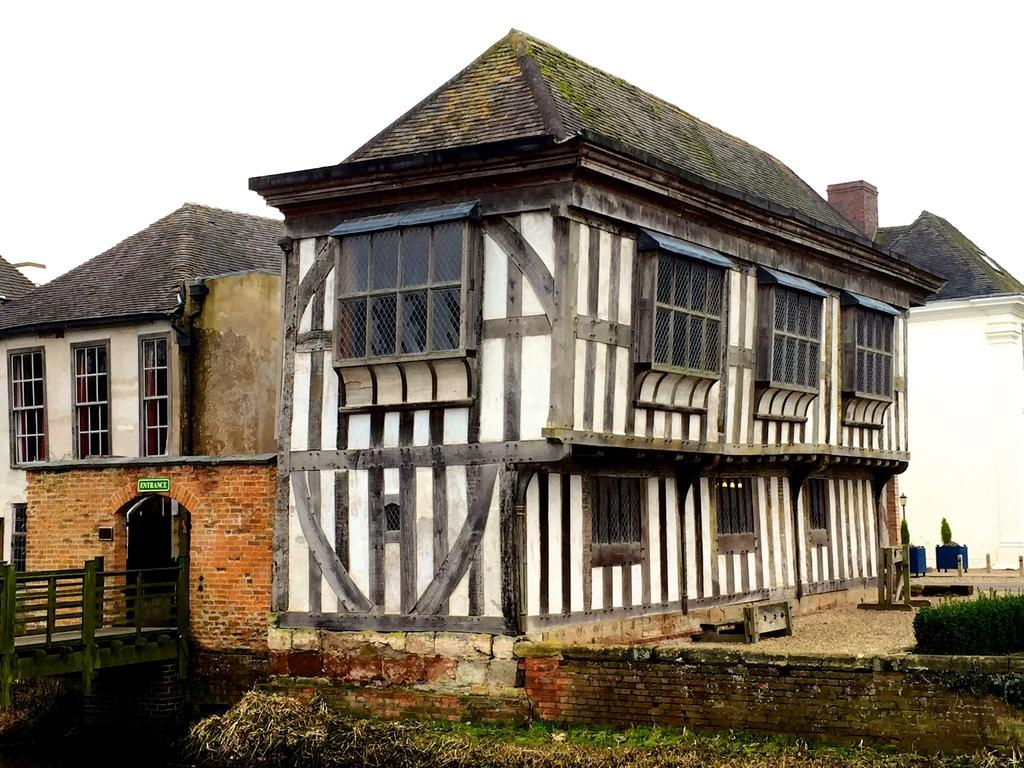What type of structures can be seen in the image? There are houses in the image. What connects the two sides of the image? There is a bridge in the image. What type of vegetation is present in the image? Grass and plants are present in the image. What is visible in the background of the image? The sky is visible in the image. Can you see a tent in the image? There is no tent present in the image. Is there an agreement being signed in the image? There is no indication of an agreement or any signing activity in the image. 